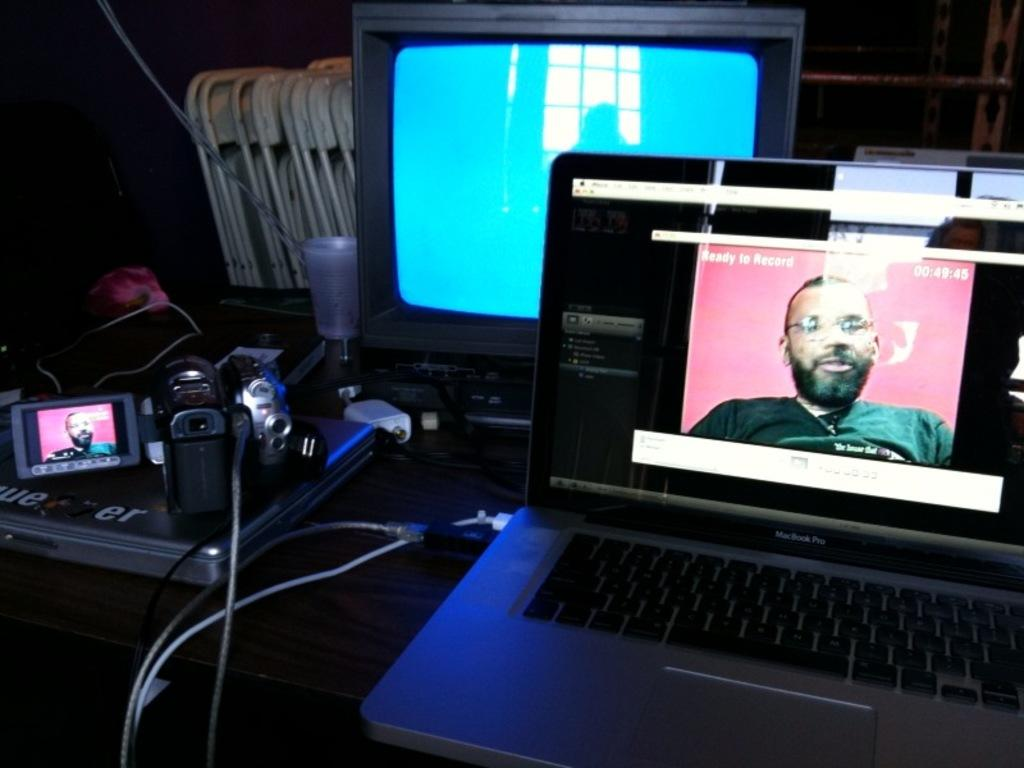<image>
Offer a succinct explanation of the picture presented. a laptop named mac book pro with tv 